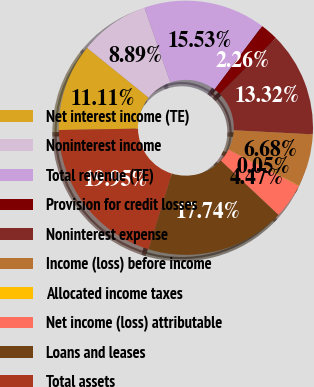<chart> <loc_0><loc_0><loc_500><loc_500><pie_chart><fcel>Net interest income (TE)<fcel>Noninterest income<fcel>Total revenue (TE)<fcel>Provision for credit losses<fcel>Noninterest expense<fcel>Income (loss) before income<fcel>Allocated income taxes<fcel>Net income (loss) attributable<fcel>Loans and leases<fcel>Total assets<nl><fcel>11.11%<fcel>8.89%<fcel>15.53%<fcel>2.26%<fcel>13.32%<fcel>6.68%<fcel>0.05%<fcel>4.47%<fcel>17.74%<fcel>19.95%<nl></chart> 